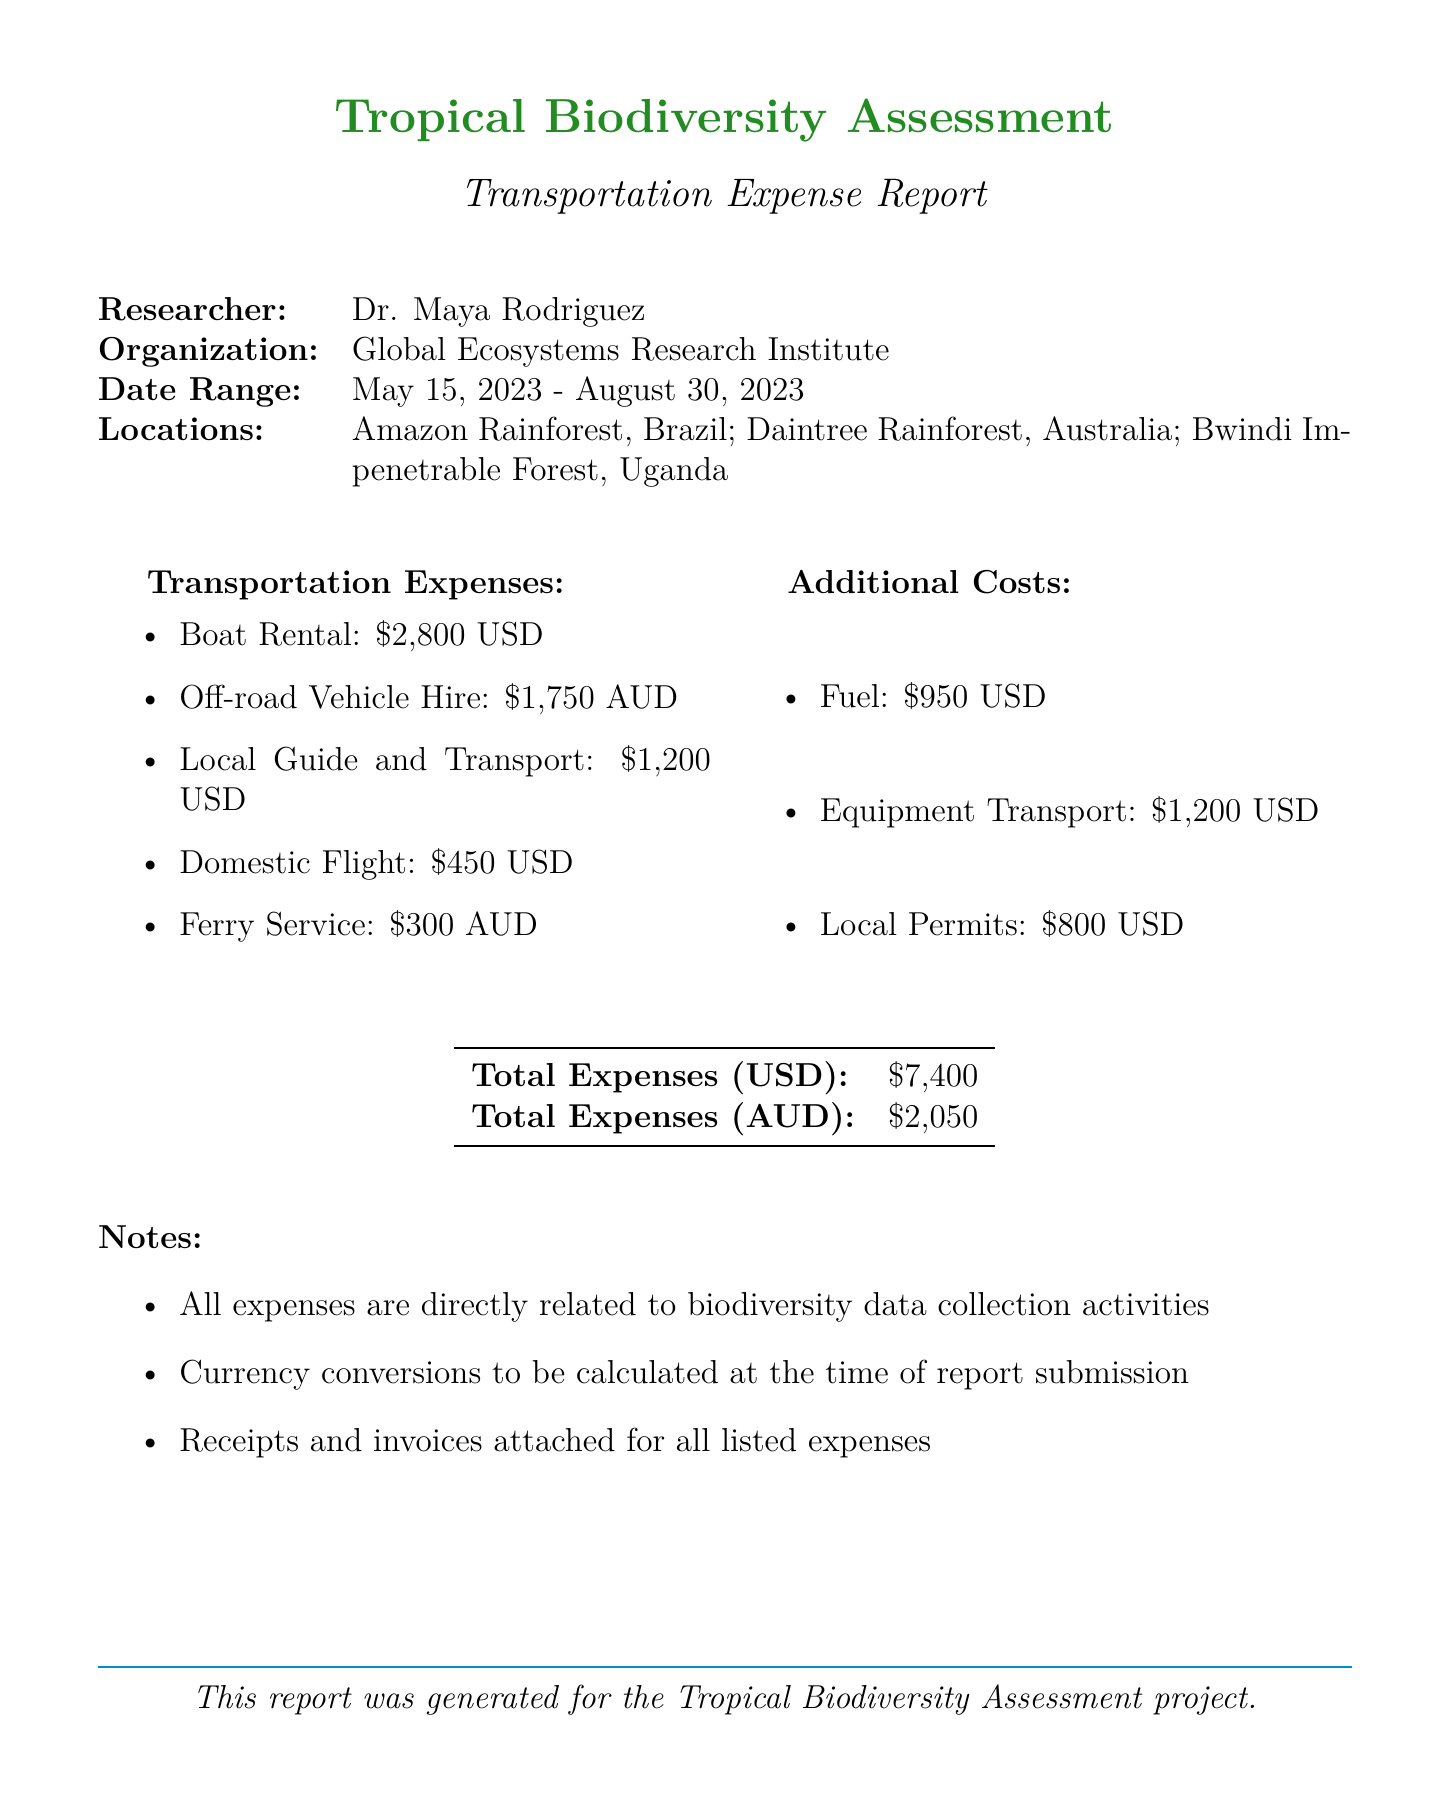what is the total expenses in USD? The total expenses in USD is provided in the document as part of the total expenses section, which sums all costs in that currency.
Answer: $7400 who is the researcher? The researcher is mentioned at the beginning of the document as part of the researcher information.
Answer: Dr. Maya Rodriguez what type of vehicle was hired for the off-road vehicle hire? The type of vehicle hired is specified in the description of the off-road vehicle hire entry in the document.
Answer: 4x4 Toyota Land Cruiser which organization is Dr. Maya Rodriguez affiliated with? The organization is given right after the researcher's name in the header section of the document.
Answer: Global Ecosystems Research Institute how many weeks was the boat rental for? The duration of the boat rental is provided in the description section of the boat rental entry in the document.
Answer: 3 weeks what additional cost is associated with shipping research equipment? The specific additional cost related to shipping research equipment is outlined in the document under additional costs.
Answer: Equipment Transport how much was paid for fuel? The amount paid for fuel is explicitly stated in the additional costs section of the document.
Answer: $950 what was the currency for the off-road vehicle hire? The currency for the off-road vehicle hire is clearly indicated next to the cost in the transportation expenses section.
Answer: AUD what is the purpose of the expenses listed in the notes? The purpose of the expenses is mentioned in the notes section to clarify their relation to the main project activity.
Answer: biodiversity data collection activities 